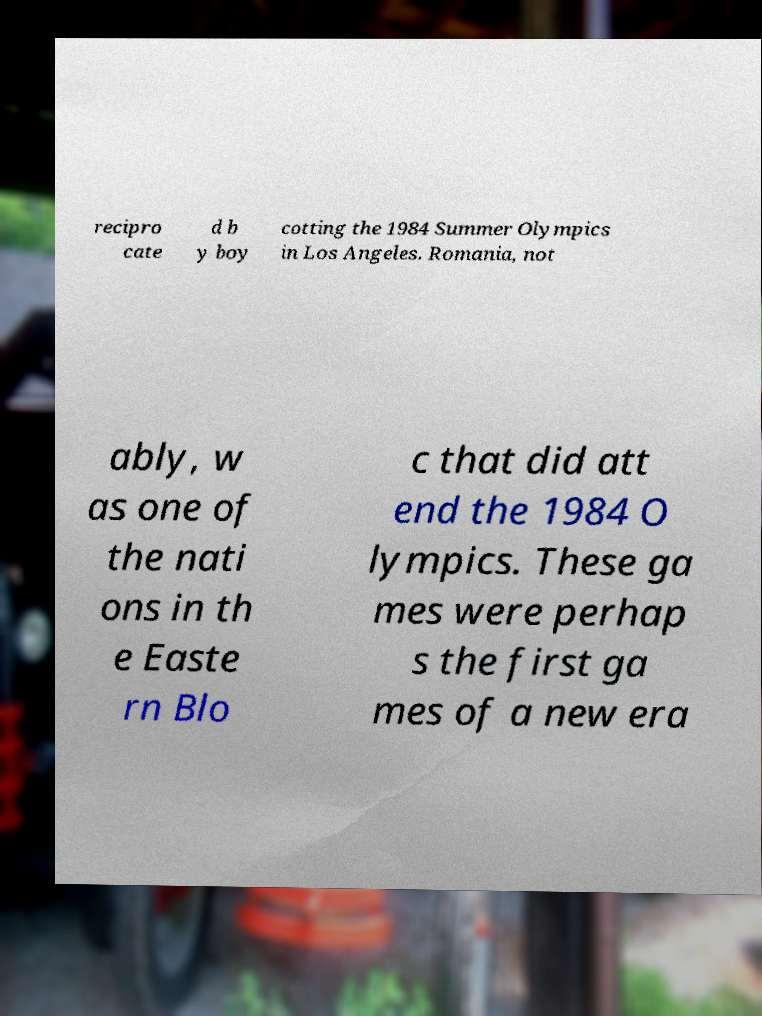For documentation purposes, I need the text within this image transcribed. Could you provide that? recipro cate d b y boy cotting the 1984 Summer Olympics in Los Angeles. Romania, not ably, w as one of the nati ons in th e Easte rn Blo c that did att end the 1984 O lympics. These ga mes were perhap s the first ga mes of a new era 